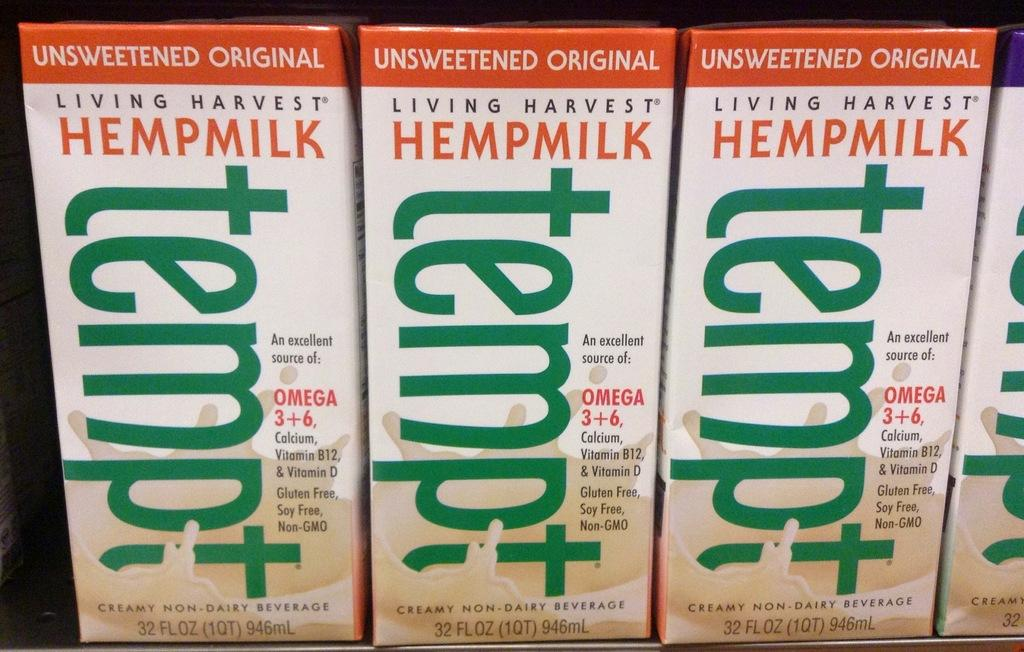<image>
Summarize the visual content of the image. A fridge full of Tempt unsweetened hemp milk . 